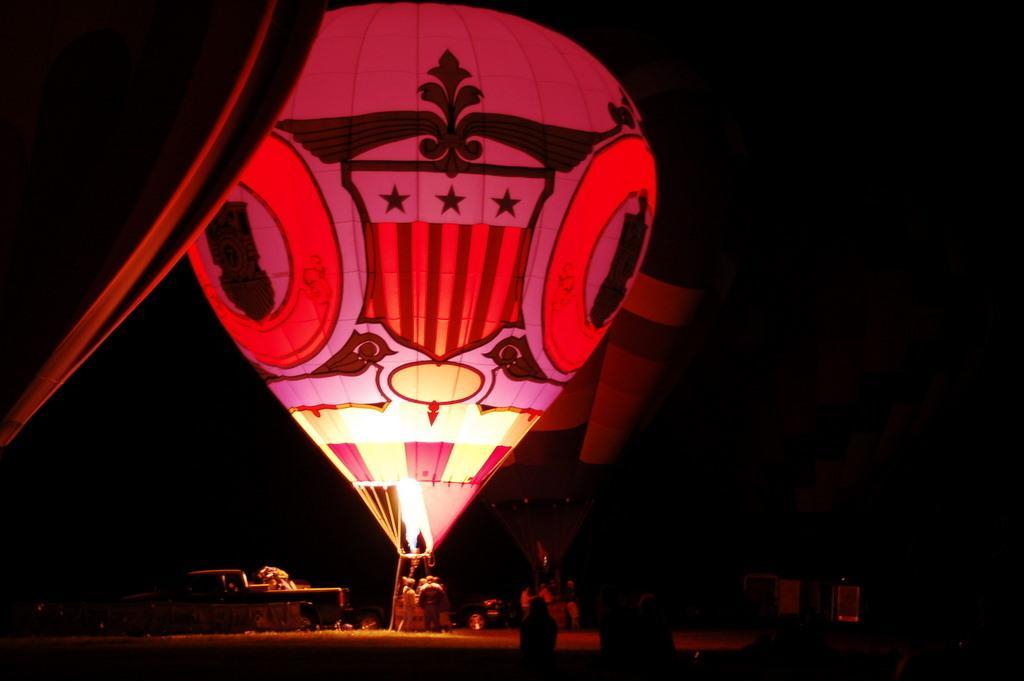Please provide a concise description of this image. In this image in the center there are parachutes, and at the bottom there are a group of people and some objects. And there is a dark background. 